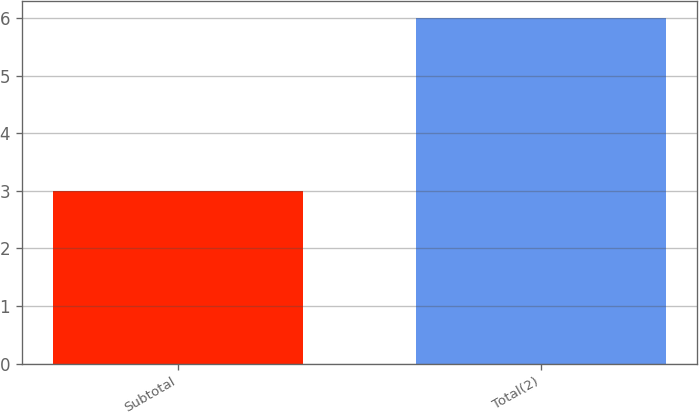Convert chart to OTSL. <chart><loc_0><loc_0><loc_500><loc_500><bar_chart><fcel>Subtotal<fcel>Total(2)<nl><fcel>3<fcel>6<nl></chart> 